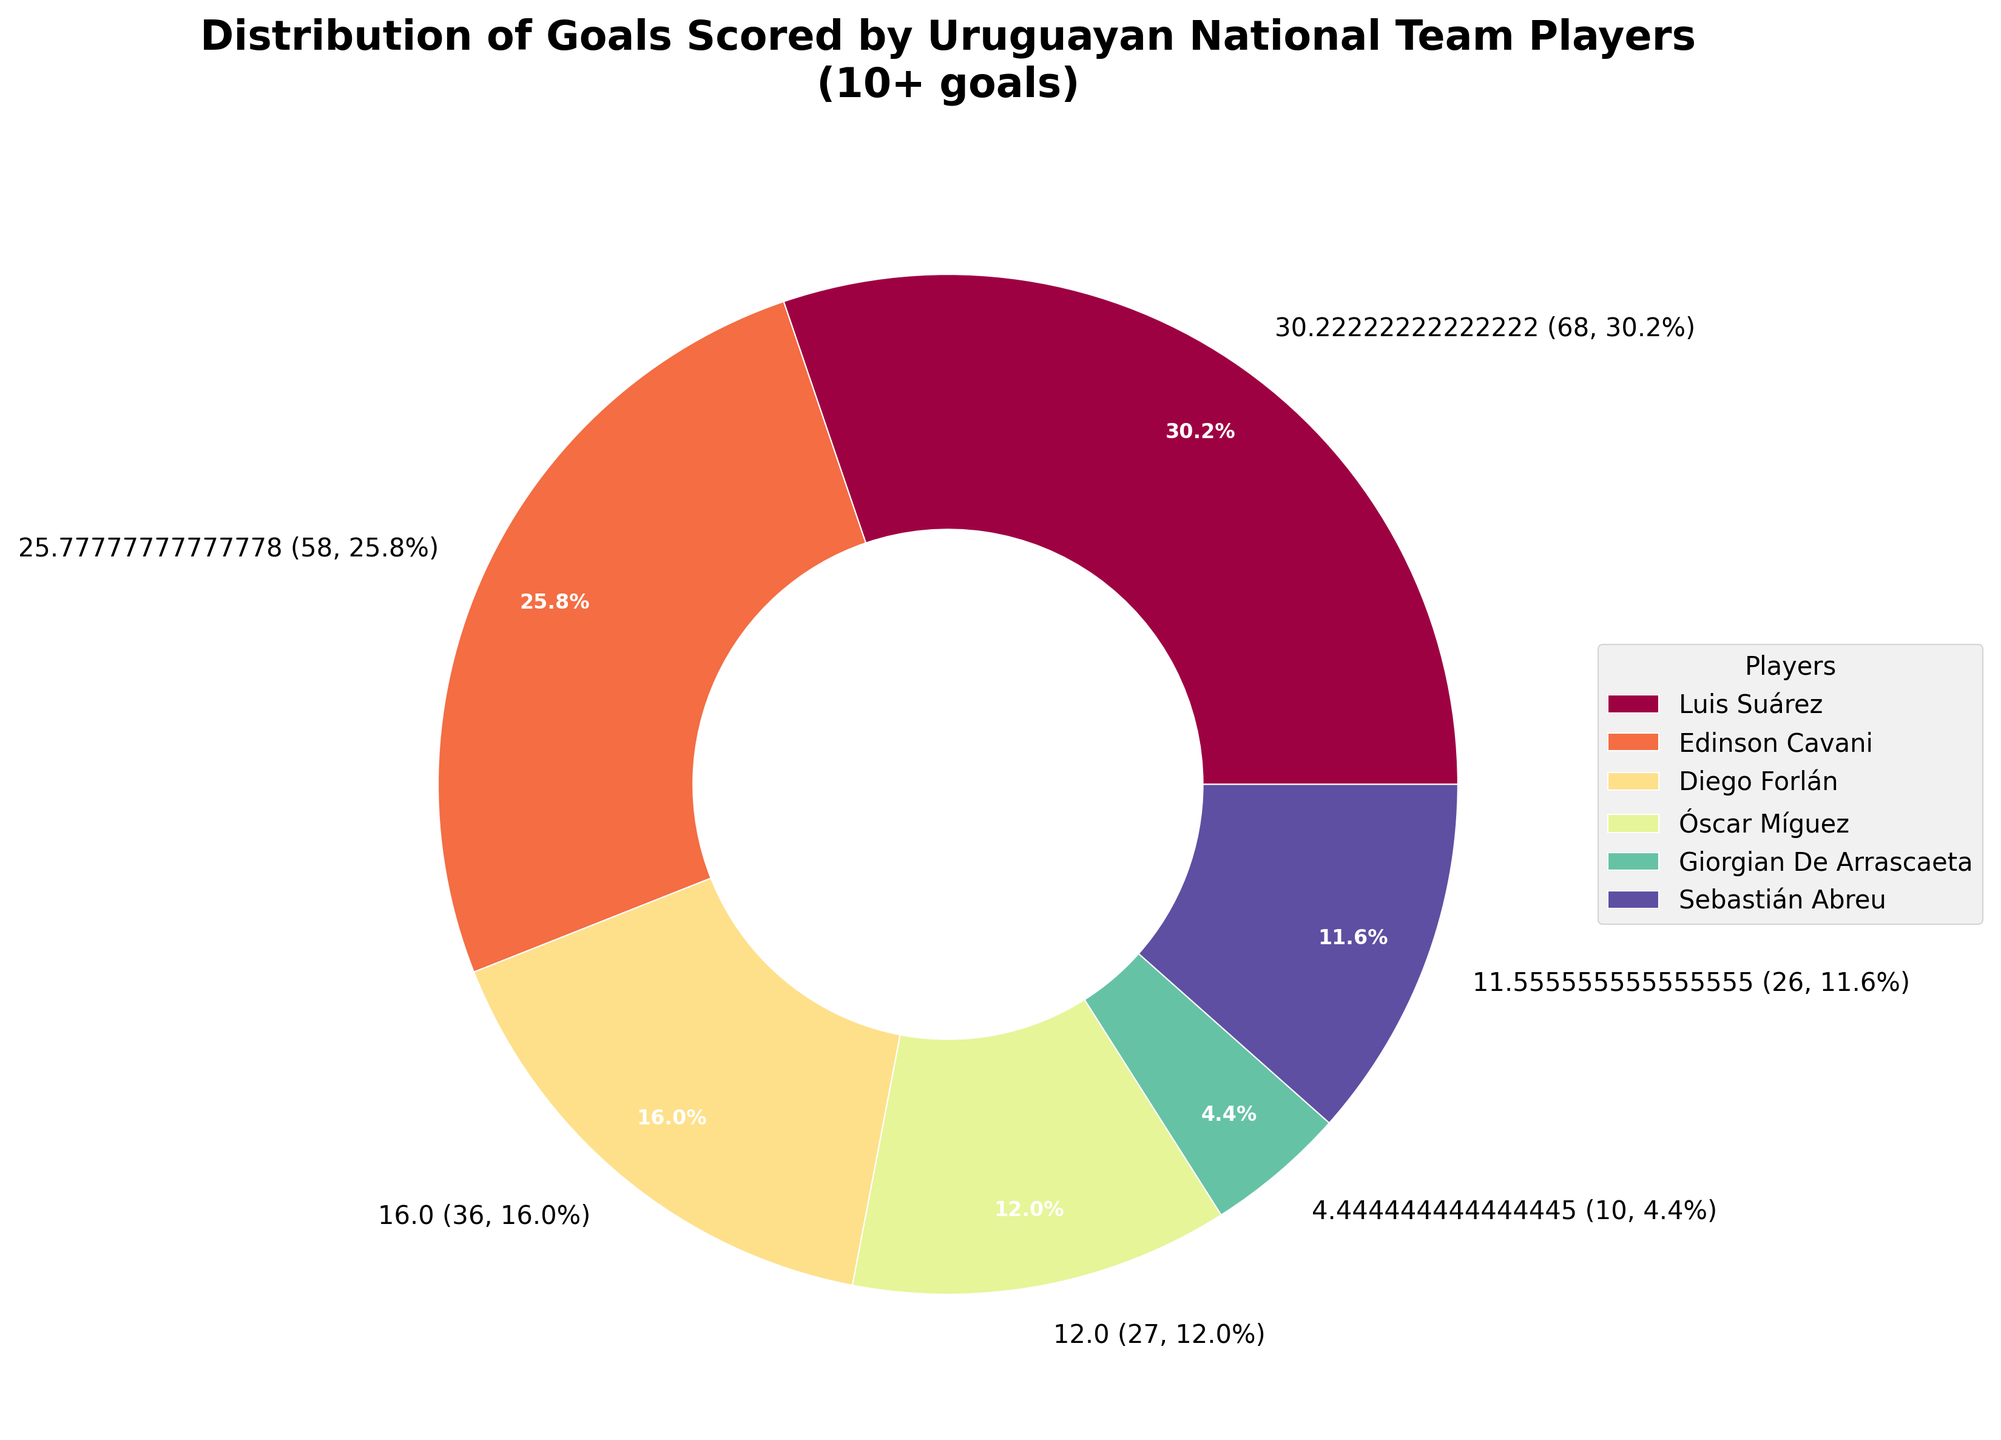Who is the top scorer for the Uruguayan national team? According to the chart, Luis Suárez has the highest number of goals compared to other players.
Answer: Luis Suárez How many goals did Edinson Cavani score compared to Diego Forlán? Edinson Cavani's segment is larger than Diego Forlán's, indicating that Cavani scored more goals. Cavani scored 58 goals, while Forlán scored 36 goals.
Answer: Edinson Cavani scored 22 more goals than Diego Forlán What percentage of the total goals were scored by Luis Suárez? Luis Suárez's segment is labeled with the percentage of total goals he contributed. According to the figure, he scored 68 goals, which amounts to a certain percentage.
Answer: 31.8% Which player has a greater scoring contribution, Óscar Míguez or Sebastián Abreu? Comparing the sizes of Óscar Míguez's and Sebastián Abreu's segments, Míguez's segment is larger. Míguez scored 27 goals compared to Abreu's 26 goals.
Answer: Óscar Míguez Summarize the total goals scored by players with fewer than 20 goals (visible in the figure). Players visible in the figure with fewer than 20 goals are: Christian Stuani (8), Nicolás Lodeiro (7), Giorgian De Arrascaeta (10). Summing these up: 8 + 7 + 10 = 25 goals by players with fewer than 20 goals.
Answer: 25 goals What is the combined percentage of goals scored by Diego Forlán and Óscar Míguez? Forlán scored 36 goals, and Míguez scored 27. First, find the total: 36 + 27 = 63. According to their percentages from the chart, adding these values: 16.8% (Forlán) + 12.6% (Míguez) = 29.4%.
Answer: 29.4% What is the difference in percentage contribution of goals between Edinson Cavani and Diego Forlán? Cavani's goal percentage is labeled at 27.1%, while Forlán's is 16.8%. The difference is found by subtracting these percentages: 27.1% - 16.8% = 10.3%.
Answer: 10.3% Which player (with greater than 10 goals) scored the least number of goals? Comparing all players, Giorgian De Arrascaeta scored 10 goals, which is the lowest in the figure for players with greater than 10 goals.
Answer: Giorgian De Arrascaeta How does the goal contribution of Diego Forlán compare to Luis Suárez in terms of percentage? Forlán's contribution is 16.8%, while Suárez's is 31.8%. To compare, Suárez's percentage is significantly higher.
Answer: Luis Suárez contributed 15% more than Diego Forlán How many players scored 30 or more goals? Observing the chart, only three players - Luis Suárez, Edinson Cavani, and Diego Forlán - have segments representing 30 or more goals.
Answer: 3 players 